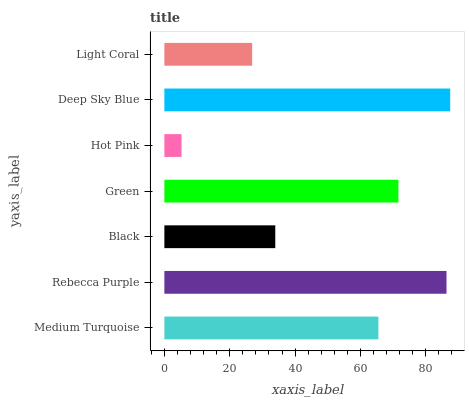Is Hot Pink the minimum?
Answer yes or no. Yes. Is Deep Sky Blue the maximum?
Answer yes or no. Yes. Is Rebecca Purple the minimum?
Answer yes or no. No. Is Rebecca Purple the maximum?
Answer yes or no. No. Is Rebecca Purple greater than Medium Turquoise?
Answer yes or no. Yes. Is Medium Turquoise less than Rebecca Purple?
Answer yes or no. Yes. Is Medium Turquoise greater than Rebecca Purple?
Answer yes or no. No. Is Rebecca Purple less than Medium Turquoise?
Answer yes or no. No. Is Medium Turquoise the high median?
Answer yes or no. Yes. Is Medium Turquoise the low median?
Answer yes or no. Yes. Is Rebecca Purple the high median?
Answer yes or no. No. Is Black the low median?
Answer yes or no. No. 